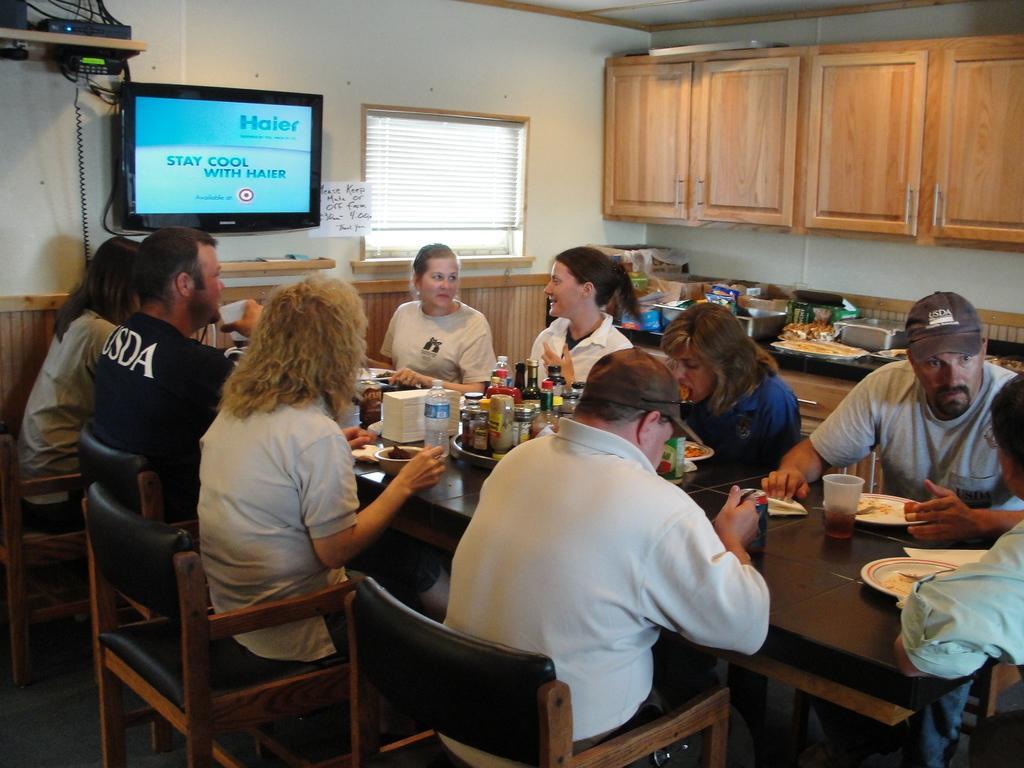Can you describe this image briefly? In this image i can see a group of people sitting on the chair and eating food. On the table we can see a few bottles and plates on it. Here we have a TV on the wall and a window. On the right side of the image we have a cupboard. On the kitchen table we can see some utensils on it. 